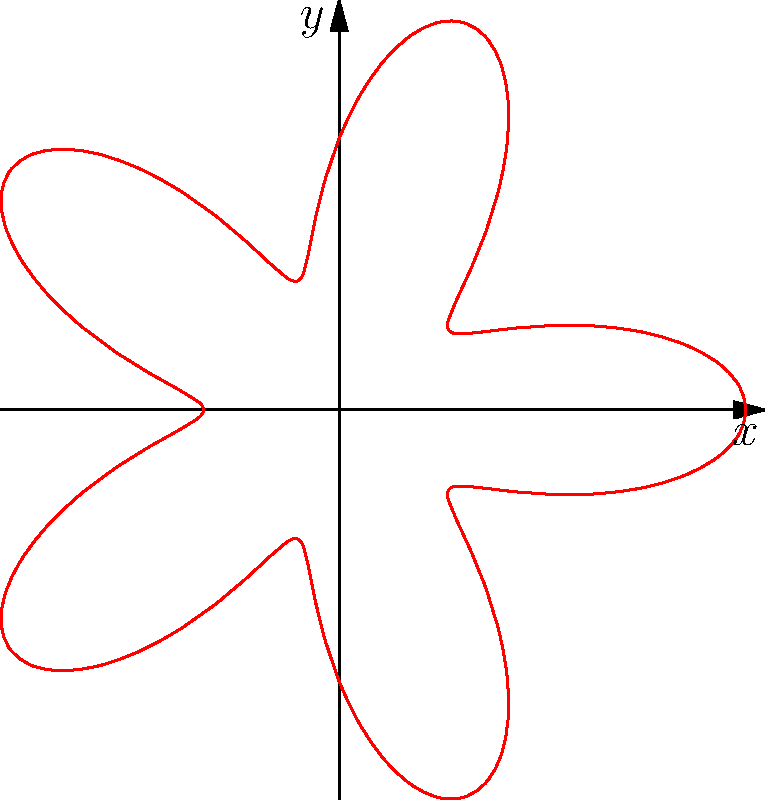A hibiscus flower's petal arrangement exhibits radial symmetry, which can be modeled using polar coordinates. The equation $r = 2 + \cos(5\theta)$ represents the outline of the flower. How many petals does this hibiscus flower have, and how does this relate to the visual presentation of Caribbean-inspired dishes? To determine the number of petals in the hibiscus flower, we need to analyze the polar equation $r = 2 + \cos(5\theta)$:

1. The cosine function completes one full cycle every $2\pi$ radians.
2. In this equation, the argument of cosine is $5\theta$, which means it completes 5 cycles in the time it takes $\theta$ to complete one full rotation $(2\pi)$.
3. Each complete cycle of the cosine function corresponds to one petal of the flower.
4. Therefore, the flower has 5 petals.

Relating this to Caribbean-inspired dishes:
1. The 5-petal symmetry of the hibiscus reflects the balance and harmony often found in Caribbean cuisine.
2. Just as each petal contributes to the overall beauty of the flower, each ingredient in a Caribbean dish contributes to its complex flavor profile.
3. The radial symmetry can inspire plating techniques, where elements of the dish are arranged in a circular pattern, mimicking the flower's structure.
4. The hibiscus itself is often used in Caribbean cuisine, particularly in teas and garnishes, connecting the mathematical model to actual culinary practices.

This mathematical representation of natural beauty can serve as inspiration for creating visually appealing and symmetrical dish presentations that reflect the vibrant and balanced nature of Caribbean flavors.
Answer: 5 petals 